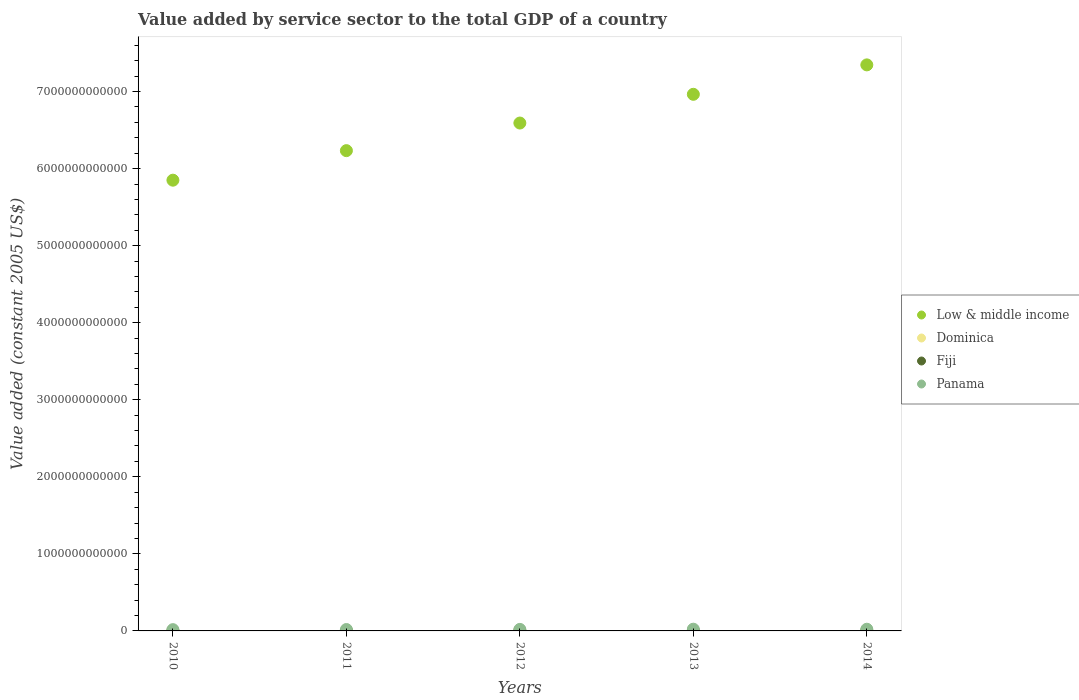Is the number of dotlines equal to the number of legend labels?
Provide a succinct answer. Yes. What is the value added by service sector in Fiji in 2013?
Give a very brief answer. 2.51e+09. Across all years, what is the maximum value added by service sector in Low & middle income?
Ensure brevity in your answer.  7.35e+12. Across all years, what is the minimum value added by service sector in Low & middle income?
Offer a terse response. 5.85e+12. In which year was the value added by service sector in Panama maximum?
Ensure brevity in your answer.  2013. In which year was the value added by service sector in Fiji minimum?
Keep it short and to the point. 2010. What is the total value added by service sector in Fiji in the graph?
Give a very brief answer. 1.19e+1. What is the difference between the value added by service sector in Low & middle income in 2012 and that in 2014?
Provide a short and direct response. -7.55e+11. What is the difference between the value added by service sector in Panama in 2014 and the value added by service sector in Low & middle income in 2012?
Give a very brief answer. -6.57e+12. What is the average value added by service sector in Fiji per year?
Your answer should be very brief. 2.37e+09. In the year 2013, what is the difference between the value added by service sector in Low & middle income and value added by service sector in Panama?
Your answer should be compact. 6.94e+12. What is the ratio of the value added by service sector in Panama in 2011 to that in 2012?
Provide a succinct answer. 0.92. Is the value added by service sector in Low & middle income in 2011 less than that in 2014?
Ensure brevity in your answer.  Yes. Is the difference between the value added by service sector in Low & middle income in 2013 and 2014 greater than the difference between the value added by service sector in Panama in 2013 and 2014?
Keep it short and to the point. No. What is the difference between the highest and the second highest value added by service sector in Panama?
Provide a succinct answer. 5.24e+08. What is the difference between the highest and the lowest value added by service sector in Dominica?
Your answer should be compact. 1.53e+07. Is the sum of the value added by service sector in Fiji in 2011 and 2012 greater than the maximum value added by service sector in Panama across all years?
Make the answer very short. No. Is the value added by service sector in Low & middle income strictly less than the value added by service sector in Panama over the years?
Provide a succinct answer. No. How many dotlines are there?
Offer a terse response. 4. How many years are there in the graph?
Ensure brevity in your answer.  5. What is the difference between two consecutive major ticks on the Y-axis?
Ensure brevity in your answer.  1.00e+12. Are the values on the major ticks of Y-axis written in scientific E-notation?
Your answer should be very brief. No. Does the graph contain any zero values?
Give a very brief answer. No. How many legend labels are there?
Ensure brevity in your answer.  4. What is the title of the graph?
Your answer should be very brief. Value added by service sector to the total GDP of a country. What is the label or title of the Y-axis?
Provide a short and direct response. Value added (constant 2005 US$). What is the Value added (constant 2005 US$) in Low & middle income in 2010?
Your response must be concise. 5.85e+12. What is the Value added (constant 2005 US$) in Dominica in 2010?
Offer a terse response. 2.59e+08. What is the Value added (constant 2005 US$) of Fiji in 2010?
Your answer should be compact. 1.95e+09. What is the Value added (constant 2005 US$) in Panama in 2010?
Offer a terse response. 1.65e+1. What is the Value added (constant 2005 US$) in Low & middle income in 2011?
Offer a very short reply. 6.23e+12. What is the Value added (constant 2005 US$) of Dominica in 2011?
Keep it short and to the point. 2.60e+08. What is the Value added (constant 2005 US$) of Fiji in 2011?
Your response must be concise. 2.33e+09. What is the Value added (constant 2005 US$) in Panama in 2011?
Give a very brief answer. 1.82e+1. What is the Value added (constant 2005 US$) in Low & middle income in 2012?
Ensure brevity in your answer.  6.59e+12. What is the Value added (constant 2005 US$) in Dominica in 2012?
Offer a terse response. 2.55e+08. What is the Value added (constant 2005 US$) of Fiji in 2012?
Offer a terse response. 2.40e+09. What is the Value added (constant 2005 US$) in Panama in 2012?
Provide a short and direct response. 1.98e+1. What is the Value added (constant 2005 US$) in Low & middle income in 2013?
Give a very brief answer. 6.96e+12. What is the Value added (constant 2005 US$) of Dominica in 2013?
Keep it short and to the point. 2.60e+08. What is the Value added (constant 2005 US$) of Fiji in 2013?
Provide a short and direct response. 2.51e+09. What is the Value added (constant 2005 US$) of Panama in 2013?
Your answer should be very brief. 2.24e+1. What is the Value added (constant 2005 US$) of Low & middle income in 2014?
Keep it short and to the point. 7.35e+12. What is the Value added (constant 2005 US$) of Dominica in 2014?
Make the answer very short. 2.70e+08. What is the Value added (constant 2005 US$) of Fiji in 2014?
Your answer should be compact. 2.68e+09. What is the Value added (constant 2005 US$) in Panama in 2014?
Make the answer very short. 2.19e+1. Across all years, what is the maximum Value added (constant 2005 US$) of Low & middle income?
Your response must be concise. 7.35e+12. Across all years, what is the maximum Value added (constant 2005 US$) in Dominica?
Offer a terse response. 2.70e+08. Across all years, what is the maximum Value added (constant 2005 US$) in Fiji?
Ensure brevity in your answer.  2.68e+09. Across all years, what is the maximum Value added (constant 2005 US$) in Panama?
Offer a terse response. 2.24e+1. Across all years, what is the minimum Value added (constant 2005 US$) of Low & middle income?
Offer a very short reply. 5.85e+12. Across all years, what is the minimum Value added (constant 2005 US$) of Dominica?
Offer a very short reply. 2.55e+08. Across all years, what is the minimum Value added (constant 2005 US$) in Fiji?
Make the answer very short. 1.95e+09. Across all years, what is the minimum Value added (constant 2005 US$) in Panama?
Your response must be concise. 1.65e+1. What is the total Value added (constant 2005 US$) of Low & middle income in the graph?
Your response must be concise. 3.30e+13. What is the total Value added (constant 2005 US$) in Dominica in the graph?
Offer a terse response. 1.30e+09. What is the total Value added (constant 2005 US$) of Fiji in the graph?
Give a very brief answer. 1.19e+1. What is the total Value added (constant 2005 US$) of Panama in the graph?
Provide a succinct answer. 9.90e+1. What is the difference between the Value added (constant 2005 US$) of Low & middle income in 2010 and that in 2011?
Your answer should be very brief. -3.83e+11. What is the difference between the Value added (constant 2005 US$) of Dominica in 2010 and that in 2011?
Provide a short and direct response. -8.58e+05. What is the difference between the Value added (constant 2005 US$) in Fiji in 2010 and that in 2011?
Offer a very short reply. -3.80e+08. What is the difference between the Value added (constant 2005 US$) of Panama in 2010 and that in 2011?
Provide a short and direct response. -1.68e+09. What is the difference between the Value added (constant 2005 US$) in Low & middle income in 2010 and that in 2012?
Your answer should be very brief. -7.42e+11. What is the difference between the Value added (constant 2005 US$) in Dominica in 2010 and that in 2012?
Your answer should be very brief. 4.85e+06. What is the difference between the Value added (constant 2005 US$) of Fiji in 2010 and that in 2012?
Provide a succinct answer. -4.51e+08. What is the difference between the Value added (constant 2005 US$) of Panama in 2010 and that in 2012?
Your answer should be compact. -3.31e+09. What is the difference between the Value added (constant 2005 US$) of Low & middle income in 2010 and that in 2013?
Offer a terse response. -1.11e+12. What is the difference between the Value added (constant 2005 US$) of Dominica in 2010 and that in 2013?
Offer a terse response. -1.63e+05. What is the difference between the Value added (constant 2005 US$) of Fiji in 2010 and that in 2013?
Give a very brief answer. -5.59e+08. What is the difference between the Value added (constant 2005 US$) in Panama in 2010 and that in 2013?
Provide a short and direct response. -5.91e+09. What is the difference between the Value added (constant 2005 US$) of Low & middle income in 2010 and that in 2014?
Your answer should be very brief. -1.50e+12. What is the difference between the Value added (constant 2005 US$) in Dominica in 2010 and that in 2014?
Your response must be concise. -1.04e+07. What is the difference between the Value added (constant 2005 US$) in Fiji in 2010 and that in 2014?
Make the answer very short. -7.32e+08. What is the difference between the Value added (constant 2005 US$) of Panama in 2010 and that in 2014?
Provide a succinct answer. -5.38e+09. What is the difference between the Value added (constant 2005 US$) of Low & middle income in 2011 and that in 2012?
Your answer should be very brief. -3.58e+11. What is the difference between the Value added (constant 2005 US$) in Dominica in 2011 and that in 2012?
Offer a very short reply. 5.71e+06. What is the difference between the Value added (constant 2005 US$) of Fiji in 2011 and that in 2012?
Keep it short and to the point. -7.08e+07. What is the difference between the Value added (constant 2005 US$) of Panama in 2011 and that in 2012?
Offer a very short reply. -1.63e+09. What is the difference between the Value added (constant 2005 US$) in Low & middle income in 2011 and that in 2013?
Your answer should be compact. -7.31e+11. What is the difference between the Value added (constant 2005 US$) of Dominica in 2011 and that in 2013?
Give a very brief answer. 6.94e+05. What is the difference between the Value added (constant 2005 US$) in Fiji in 2011 and that in 2013?
Your answer should be compact. -1.79e+08. What is the difference between the Value added (constant 2005 US$) of Panama in 2011 and that in 2013?
Provide a short and direct response. -4.23e+09. What is the difference between the Value added (constant 2005 US$) of Low & middle income in 2011 and that in 2014?
Provide a short and direct response. -1.11e+12. What is the difference between the Value added (constant 2005 US$) in Dominica in 2011 and that in 2014?
Your answer should be compact. -9.54e+06. What is the difference between the Value added (constant 2005 US$) of Fiji in 2011 and that in 2014?
Your response must be concise. -3.52e+08. What is the difference between the Value added (constant 2005 US$) in Panama in 2011 and that in 2014?
Your answer should be compact. -3.70e+09. What is the difference between the Value added (constant 2005 US$) in Low & middle income in 2012 and that in 2013?
Your answer should be very brief. -3.73e+11. What is the difference between the Value added (constant 2005 US$) of Dominica in 2012 and that in 2013?
Provide a succinct answer. -5.02e+06. What is the difference between the Value added (constant 2005 US$) in Fiji in 2012 and that in 2013?
Provide a short and direct response. -1.08e+08. What is the difference between the Value added (constant 2005 US$) of Panama in 2012 and that in 2013?
Provide a succinct answer. -2.60e+09. What is the difference between the Value added (constant 2005 US$) in Low & middle income in 2012 and that in 2014?
Ensure brevity in your answer.  -7.55e+11. What is the difference between the Value added (constant 2005 US$) in Dominica in 2012 and that in 2014?
Your answer should be compact. -1.53e+07. What is the difference between the Value added (constant 2005 US$) of Fiji in 2012 and that in 2014?
Make the answer very short. -2.81e+08. What is the difference between the Value added (constant 2005 US$) of Panama in 2012 and that in 2014?
Give a very brief answer. -2.07e+09. What is the difference between the Value added (constant 2005 US$) in Low & middle income in 2013 and that in 2014?
Offer a very short reply. -3.82e+11. What is the difference between the Value added (constant 2005 US$) of Dominica in 2013 and that in 2014?
Your answer should be compact. -1.02e+07. What is the difference between the Value added (constant 2005 US$) in Fiji in 2013 and that in 2014?
Ensure brevity in your answer.  -1.73e+08. What is the difference between the Value added (constant 2005 US$) of Panama in 2013 and that in 2014?
Make the answer very short. 5.24e+08. What is the difference between the Value added (constant 2005 US$) of Low & middle income in 2010 and the Value added (constant 2005 US$) of Dominica in 2011?
Ensure brevity in your answer.  5.85e+12. What is the difference between the Value added (constant 2005 US$) of Low & middle income in 2010 and the Value added (constant 2005 US$) of Fiji in 2011?
Provide a succinct answer. 5.85e+12. What is the difference between the Value added (constant 2005 US$) in Low & middle income in 2010 and the Value added (constant 2005 US$) in Panama in 2011?
Your answer should be compact. 5.83e+12. What is the difference between the Value added (constant 2005 US$) of Dominica in 2010 and the Value added (constant 2005 US$) of Fiji in 2011?
Your response must be concise. -2.07e+09. What is the difference between the Value added (constant 2005 US$) of Dominica in 2010 and the Value added (constant 2005 US$) of Panama in 2011?
Make the answer very short. -1.80e+1. What is the difference between the Value added (constant 2005 US$) in Fiji in 2010 and the Value added (constant 2005 US$) in Panama in 2011?
Your answer should be very brief. -1.63e+1. What is the difference between the Value added (constant 2005 US$) of Low & middle income in 2010 and the Value added (constant 2005 US$) of Dominica in 2012?
Provide a succinct answer. 5.85e+12. What is the difference between the Value added (constant 2005 US$) in Low & middle income in 2010 and the Value added (constant 2005 US$) in Fiji in 2012?
Give a very brief answer. 5.85e+12. What is the difference between the Value added (constant 2005 US$) of Low & middle income in 2010 and the Value added (constant 2005 US$) of Panama in 2012?
Offer a very short reply. 5.83e+12. What is the difference between the Value added (constant 2005 US$) in Dominica in 2010 and the Value added (constant 2005 US$) in Fiji in 2012?
Give a very brief answer. -2.14e+09. What is the difference between the Value added (constant 2005 US$) in Dominica in 2010 and the Value added (constant 2005 US$) in Panama in 2012?
Offer a terse response. -1.96e+1. What is the difference between the Value added (constant 2005 US$) of Fiji in 2010 and the Value added (constant 2005 US$) of Panama in 2012?
Offer a terse response. -1.79e+1. What is the difference between the Value added (constant 2005 US$) of Low & middle income in 2010 and the Value added (constant 2005 US$) of Dominica in 2013?
Keep it short and to the point. 5.85e+12. What is the difference between the Value added (constant 2005 US$) of Low & middle income in 2010 and the Value added (constant 2005 US$) of Fiji in 2013?
Give a very brief answer. 5.85e+12. What is the difference between the Value added (constant 2005 US$) of Low & middle income in 2010 and the Value added (constant 2005 US$) of Panama in 2013?
Your answer should be very brief. 5.83e+12. What is the difference between the Value added (constant 2005 US$) in Dominica in 2010 and the Value added (constant 2005 US$) in Fiji in 2013?
Your answer should be very brief. -2.25e+09. What is the difference between the Value added (constant 2005 US$) in Dominica in 2010 and the Value added (constant 2005 US$) in Panama in 2013?
Provide a succinct answer. -2.22e+1. What is the difference between the Value added (constant 2005 US$) of Fiji in 2010 and the Value added (constant 2005 US$) of Panama in 2013?
Keep it short and to the point. -2.05e+1. What is the difference between the Value added (constant 2005 US$) of Low & middle income in 2010 and the Value added (constant 2005 US$) of Dominica in 2014?
Your answer should be very brief. 5.85e+12. What is the difference between the Value added (constant 2005 US$) in Low & middle income in 2010 and the Value added (constant 2005 US$) in Fiji in 2014?
Keep it short and to the point. 5.85e+12. What is the difference between the Value added (constant 2005 US$) of Low & middle income in 2010 and the Value added (constant 2005 US$) of Panama in 2014?
Give a very brief answer. 5.83e+12. What is the difference between the Value added (constant 2005 US$) of Dominica in 2010 and the Value added (constant 2005 US$) of Fiji in 2014?
Keep it short and to the point. -2.42e+09. What is the difference between the Value added (constant 2005 US$) in Dominica in 2010 and the Value added (constant 2005 US$) in Panama in 2014?
Your answer should be compact. -2.17e+1. What is the difference between the Value added (constant 2005 US$) in Fiji in 2010 and the Value added (constant 2005 US$) in Panama in 2014?
Provide a succinct answer. -2.00e+1. What is the difference between the Value added (constant 2005 US$) in Low & middle income in 2011 and the Value added (constant 2005 US$) in Dominica in 2012?
Keep it short and to the point. 6.23e+12. What is the difference between the Value added (constant 2005 US$) of Low & middle income in 2011 and the Value added (constant 2005 US$) of Fiji in 2012?
Your answer should be compact. 6.23e+12. What is the difference between the Value added (constant 2005 US$) of Low & middle income in 2011 and the Value added (constant 2005 US$) of Panama in 2012?
Offer a very short reply. 6.21e+12. What is the difference between the Value added (constant 2005 US$) of Dominica in 2011 and the Value added (constant 2005 US$) of Fiji in 2012?
Your response must be concise. -2.14e+09. What is the difference between the Value added (constant 2005 US$) of Dominica in 2011 and the Value added (constant 2005 US$) of Panama in 2012?
Offer a terse response. -1.96e+1. What is the difference between the Value added (constant 2005 US$) of Fiji in 2011 and the Value added (constant 2005 US$) of Panama in 2012?
Offer a terse response. -1.75e+1. What is the difference between the Value added (constant 2005 US$) of Low & middle income in 2011 and the Value added (constant 2005 US$) of Dominica in 2013?
Keep it short and to the point. 6.23e+12. What is the difference between the Value added (constant 2005 US$) in Low & middle income in 2011 and the Value added (constant 2005 US$) in Fiji in 2013?
Your answer should be compact. 6.23e+12. What is the difference between the Value added (constant 2005 US$) of Low & middle income in 2011 and the Value added (constant 2005 US$) of Panama in 2013?
Offer a terse response. 6.21e+12. What is the difference between the Value added (constant 2005 US$) in Dominica in 2011 and the Value added (constant 2005 US$) in Fiji in 2013?
Make the answer very short. -2.25e+09. What is the difference between the Value added (constant 2005 US$) in Dominica in 2011 and the Value added (constant 2005 US$) in Panama in 2013?
Provide a succinct answer. -2.22e+1. What is the difference between the Value added (constant 2005 US$) of Fiji in 2011 and the Value added (constant 2005 US$) of Panama in 2013?
Offer a terse response. -2.01e+1. What is the difference between the Value added (constant 2005 US$) in Low & middle income in 2011 and the Value added (constant 2005 US$) in Dominica in 2014?
Provide a short and direct response. 6.23e+12. What is the difference between the Value added (constant 2005 US$) of Low & middle income in 2011 and the Value added (constant 2005 US$) of Fiji in 2014?
Ensure brevity in your answer.  6.23e+12. What is the difference between the Value added (constant 2005 US$) in Low & middle income in 2011 and the Value added (constant 2005 US$) in Panama in 2014?
Your answer should be very brief. 6.21e+12. What is the difference between the Value added (constant 2005 US$) in Dominica in 2011 and the Value added (constant 2005 US$) in Fiji in 2014?
Keep it short and to the point. -2.42e+09. What is the difference between the Value added (constant 2005 US$) of Dominica in 2011 and the Value added (constant 2005 US$) of Panama in 2014?
Your answer should be very brief. -2.17e+1. What is the difference between the Value added (constant 2005 US$) of Fiji in 2011 and the Value added (constant 2005 US$) of Panama in 2014?
Your answer should be very brief. -1.96e+1. What is the difference between the Value added (constant 2005 US$) in Low & middle income in 2012 and the Value added (constant 2005 US$) in Dominica in 2013?
Give a very brief answer. 6.59e+12. What is the difference between the Value added (constant 2005 US$) of Low & middle income in 2012 and the Value added (constant 2005 US$) of Fiji in 2013?
Make the answer very short. 6.59e+12. What is the difference between the Value added (constant 2005 US$) of Low & middle income in 2012 and the Value added (constant 2005 US$) of Panama in 2013?
Your answer should be compact. 6.57e+12. What is the difference between the Value added (constant 2005 US$) in Dominica in 2012 and the Value added (constant 2005 US$) in Fiji in 2013?
Provide a succinct answer. -2.25e+09. What is the difference between the Value added (constant 2005 US$) of Dominica in 2012 and the Value added (constant 2005 US$) of Panama in 2013?
Your answer should be compact. -2.22e+1. What is the difference between the Value added (constant 2005 US$) of Fiji in 2012 and the Value added (constant 2005 US$) of Panama in 2013?
Ensure brevity in your answer.  -2.00e+1. What is the difference between the Value added (constant 2005 US$) of Low & middle income in 2012 and the Value added (constant 2005 US$) of Dominica in 2014?
Your response must be concise. 6.59e+12. What is the difference between the Value added (constant 2005 US$) in Low & middle income in 2012 and the Value added (constant 2005 US$) in Fiji in 2014?
Make the answer very short. 6.59e+12. What is the difference between the Value added (constant 2005 US$) in Low & middle income in 2012 and the Value added (constant 2005 US$) in Panama in 2014?
Offer a terse response. 6.57e+12. What is the difference between the Value added (constant 2005 US$) in Dominica in 2012 and the Value added (constant 2005 US$) in Fiji in 2014?
Offer a very short reply. -2.43e+09. What is the difference between the Value added (constant 2005 US$) in Dominica in 2012 and the Value added (constant 2005 US$) in Panama in 2014?
Keep it short and to the point. -2.17e+1. What is the difference between the Value added (constant 2005 US$) in Fiji in 2012 and the Value added (constant 2005 US$) in Panama in 2014?
Your answer should be very brief. -1.95e+1. What is the difference between the Value added (constant 2005 US$) of Low & middle income in 2013 and the Value added (constant 2005 US$) of Dominica in 2014?
Offer a terse response. 6.96e+12. What is the difference between the Value added (constant 2005 US$) of Low & middle income in 2013 and the Value added (constant 2005 US$) of Fiji in 2014?
Offer a very short reply. 6.96e+12. What is the difference between the Value added (constant 2005 US$) of Low & middle income in 2013 and the Value added (constant 2005 US$) of Panama in 2014?
Offer a terse response. 6.94e+12. What is the difference between the Value added (constant 2005 US$) in Dominica in 2013 and the Value added (constant 2005 US$) in Fiji in 2014?
Keep it short and to the point. -2.42e+09. What is the difference between the Value added (constant 2005 US$) in Dominica in 2013 and the Value added (constant 2005 US$) in Panama in 2014?
Your answer should be very brief. -2.17e+1. What is the difference between the Value added (constant 2005 US$) of Fiji in 2013 and the Value added (constant 2005 US$) of Panama in 2014?
Make the answer very short. -1.94e+1. What is the average Value added (constant 2005 US$) in Low & middle income per year?
Your response must be concise. 6.60e+12. What is the average Value added (constant 2005 US$) in Dominica per year?
Your response must be concise. 2.61e+08. What is the average Value added (constant 2005 US$) in Fiji per year?
Offer a very short reply. 2.37e+09. What is the average Value added (constant 2005 US$) of Panama per year?
Give a very brief answer. 1.98e+1. In the year 2010, what is the difference between the Value added (constant 2005 US$) of Low & middle income and Value added (constant 2005 US$) of Dominica?
Make the answer very short. 5.85e+12. In the year 2010, what is the difference between the Value added (constant 2005 US$) of Low & middle income and Value added (constant 2005 US$) of Fiji?
Your answer should be compact. 5.85e+12. In the year 2010, what is the difference between the Value added (constant 2005 US$) in Low & middle income and Value added (constant 2005 US$) in Panama?
Offer a very short reply. 5.83e+12. In the year 2010, what is the difference between the Value added (constant 2005 US$) in Dominica and Value added (constant 2005 US$) in Fiji?
Your response must be concise. -1.69e+09. In the year 2010, what is the difference between the Value added (constant 2005 US$) of Dominica and Value added (constant 2005 US$) of Panama?
Offer a very short reply. -1.63e+1. In the year 2010, what is the difference between the Value added (constant 2005 US$) in Fiji and Value added (constant 2005 US$) in Panama?
Give a very brief answer. -1.46e+1. In the year 2011, what is the difference between the Value added (constant 2005 US$) of Low & middle income and Value added (constant 2005 US$) of Dominica?
Make the answer very short. 6.23e+12. In the year 2011, what is the difference between the Value added (constant 2005 US$) of Low & middle income and Value added (constant 2005 US$) of Fiji?
Provide a succinct answer. 6.23e+12. In the year 2011, what is the difference between the Value added (constant 2005 US$) in Low & middle income and Value added (constant 2005 US$) in Panama?
Your answer should be very brief. 6.21e+12. In the year 2011, what is the difference between the Value added (constant 2005 US$) in Dominica and Value added (constant 2005 US$) in Fiji?
Your response must be concise. -2.07e+09. In the year 2011, what is the difference between the Value added (constant 2005 US$) of Dominica and Value added (constant 2005 US$) of Panama?
Give a very brief answer. -1.80e+1. In the year 2011, what is the difference between the Value added (constant 2005 US$) in Fiji and Value added (constant 2005 US$) in Panama?
Your response must be concise. -1.59e+1. In the year 2012, what is the difference between the Value added (constant 2005 US$) in Low & middle income and Value added (constant 2005 US$) in Dominica?
Make the answer very short. 6.59e+12. In the year 2012, what is the difference between the Value added (constant 2005 US$) in Low & middle income and Value added (constant 2005 US$) in Fiji?
Make the answer very short. 6.59e+12. In the year 2012, what is the difference between the Value added (constant 2005 US$) of Low & middle income and Value added (constant 2005 US$) of Panama?
Keep it short and to the point. 6.57e+12. In the year 2012, what is the difference between the Value added (constant 2005 US$) of Dominica and Value added (constant 2005 US$) of Fiji?
Your answer should be compact. -2.14e+09. In the year 2012, what is the difference between the Value added (constant 2005 US$) of Dominica and Value added (constant 2005 US$) of Panama?
Your answer should be very brief. -1.96e+1. In the year 2012, what is the difference between the Value added (constant 2005 US$) of Fiji and Value added (constant 2005 US$) of Panama?
Offer a terse response. -1.74e+1. In the year 2013, what is the difference between the Value added (constant 2005 US$) of Low & middle income and Value added (constant 2005 US$) of Dominica?
Ensure brevity in your answer.  6.96e+12. In the year 2013, what is the difference between the Value added (constant 2005 US$) of Low & middle income and Value added (constant 2005 US$) of Fiji?
Your answer should be compact. 6.96e+12. In the year 2013, what is the difference between the Value added (constant 2005 US$) of Low & middle income and Value added (constant 2005 US$) of Panama?
Offer a very short reply. 6.94e+12. In the year 2013, what is the difference between the Value added (constant 2005 US$) in Dominica and Value added (constant 2005 US$) in Fiji?
Your answer should be very brief. -2.25e+09. In the year 2013, what is the difference between the Value added (constant 2005 US$) of Dominica and Value added (constant 2005 US$) of Panama?
Offer a terse response. -2.22e+1. In the year 2013, what is the difference between the Value added (constant 2005 US$) of Fiji and Value added (constant 2005 US$) of Panama?
Your response must be concise. -1.99e+1. In the year 2014, what is the difference between the Value added (constant 2005 US$) in Low & middle income and Value added (constant 2005 US$) in Dominica?
Keep it short and to the point. 7.35e+12. In the year 2014, what is the difference between the Value added (constant 2005 US$) in Low & middle income and Value added (constant 2005 US$) in Fiji?
Your response must be concise. 7.34e+12. In the year 2014, what is the difference between the Value added (constant 2005 US$) in Low & middle income and Value added (constant 2005 US$) in Panama?
Your answer should be very brief. 7.32e+12. In the year 2014, what is the difference between the Value added (constant 2005 US$) of Dominica and Value added (constant 2005 US$) of Fiji?
Provide a succinct answer. -2.41e+09. In the year 2014, what is the difference between the Value added (constant 2005 US$) in Dominica and Value added (constant 2005 US$) in Panama?
Keep it short and to the point. -2.17e+1. In the year 2014, what is the difference between the Value added (constant 2005 US$) of Fiji and Value added (constant 2005 US$) of Panama?
Your answer should be compact. -1.92e+1. What is the ratio of the Value added (constant 2005 US$) of Low & middle income in 2010 to that in 2011?
Offer a very short reply. 0.94. What is the ratio of the Value added (constant 2005 US$) of Fiji in 2010 to that in 2011?
Ensure brevity in your answer.  0.84. What is the ratio of the Value added (constant 2005 US$) of Panama in 2010 to that in 2011?
Provide a short and direct response. 0.91. What is the ratio of the Value added (constant 2005 US$) of Low & middle income in 2010 to that in 2012?
Provide a succinct answer. 0.89. What is the ratio of the Value added (constant 2005 US$) in Dominica in 2010 to that in 2012?
Your answer should be very brief. 1.02. What is the ratio of the Value added (constant 2005 US$) in Fiji in 2010 to that in 2012?
Your response must be concise. 0.81. What is the ratio of the Value added (constant 2005 US$) in Panama in 2010 to that in 2012?
Provide a short and direct response. 0.83. What is the ratio of the Value added (constant 2005 US$) in Low & middle income in 2010 to that in 2013?
Ensure brevity in your answer.  0.84. What is the ratio of the Value added (constant 2005 US$) of Dominica in 2010 to that in 2013?
Your answer should be very brief. 1. What is the ratio of the Value added (constant 2005 US$) in Fiji in 2010 to that in 2013?
Keep it short and to the point. 0.78. What is the ratio of the Value added (constant 2005 US$) in Panama in 2010 to that in 2013?
Provide a succinct answer. 0.74. What is the ratio of the Value added (constant 2005 US$) in Low & middle income in 2010 to that in 2014?
Make the answer very short. 0.8. What is the ratio of the Value added (constant 2005 US$) in Dominica in 2010 to that in 2014?
Offer a terse response. 0.96. What is the ratio of the Value added (constant 2005 US$) of Fiji in 2010 to that in 2014?
Keep it short and to the point. 0.73. What is the ratio of the Value added (constant 2005 US$) of Panama in 2010 to that in 2014?
Offer a very short reply. 0.75. What is the ratio of the Value added (constant 2005 US$) in Low & middle income in 2011 to that in 2012?
Offer a very short reply. 0.95. What is the ratio of the Value added (constant 2005 US$) in Dominica in 2011 to that in 2012?
Make the answer very short. 1.02. What is the ratio of the Value added (constant 2005 US$) of Fiji in 2011 to that in 2012?
Your answer should be very brief. 0.97. What is the ratio of the Value added (constant 2005 US$) in Panama in 2011 to that in 2012?
Keep it short and to the point. 0.92. What is the ratio of the Value added (constant 2005 US$) in Low & middle income in 2011 to that in 2013?
Your answer should be very brief. 0.9. What is the ratio of the Value added (constant 2005 US$) of Dominica in 2011 to that in 2013?
Your response must be concise. 1. What is the ratio of the Value added (constant 2005 US$) in Fiji in 2011 to that in 2013?
Offer a very short reply. 0.93. What is the ratio of the Value added (constant 2005 US$) of Panama in 2011 to that in 2013?
Provide a short and direct response. 0.81. What is the ratio of the Value added (constant 2005 US$) in Low & middle income in 2011 to that in 2014?
Keep it short and to the point. 0.85. What is the ratio of the Value added (constant 2005 US$) of Dominica in 2011 to that in 2014?
Ensure brevity in your answer.  0.96. What is the ratio of the Value added (constant 2005 US$) of Fiji in 2011 to that in 2014?
Provide a succinct answer. 0.87. What is the ratio of the Value added (constant 2005 US$) of Panama in 2011 to that in 2014?
Offer a very short reply. 0.83. What is the ratio of the Value added (constant 2005 US$) of Low & middle income in 2012 to that in 2013?
Make the answer very short. 0.95. What is the ratio of the Value added (constant 2005 US$) in Dominica in 2012 to that in 2013?
Make the answer very short. 0.98. What is the ratio of the Value added (constant 2005 US$) in Fiji in 2012 to that in 2013?
Your answer should be compact. 0.96. What is the ratio of the Value added (constant 2005 US$) of Panama in 2012 to that in 2013?
Your response must be concise. 0.88. What is the ratio of the Value added (constant 2005 US$) in Low & middle income in 2012 to that in 2014?
Ensure brevity in your answer.  0.9. What is the ratio of the Value added (constant 2005 US$) of Dominica in 2012 to that in 2014?
Your answer should be compact. 0.94. What is the ratio of the Value added (constant 2005 US$) of Fiji in 2012 to that in 2014?
Your response must be concise. 0.9. What is the ratio of the Value added (constant 2005 US$) of Panama in 2012 to that in 2014?
Offer a very short reply. 0.91. What is the ratio of the Value added (constant 2005 US$) in Low & middle income in 2013 to that in 2014?
Offer a very short reply. 0.95. What is the ratio of the Value added (constant 2005 US$) of Dominica in 2013 to that in 2014?
Ensure brevity in your answer.  0.96. What is the ratio of the Value added (constant 2005 US$) of Fiji in 2013 to that in 2014?
Make the answer very short. 0.94. What is the ratio of the Value added (constant 2005 US$) of Panama in 2013 to that in 2014?
Provide a short and direct response. 1.02. What is the difference between the highest and the second highest Value added (constant 2005 US$) in Low & middle income?
Provide a succinct answer. 3.82e+11. What is the difference between the highest and the second highest Value added (constant 2005 US$) in Dominica?
Offer a terse response. 9.54e+06. What is the difference between the highest and the second highest Value added (constant 2005 US$) in Fiji?
Provide a short and direct response. 1.73e+08. What is the difference between the highest and the second highest Value added (constant 2005 US$) of Panama?
Your answer should be very brief. 5.24e+08. What is the difference between the highest and the lowest Value added (constant 2005 US$) in Low & middle income?
Your response must be concise. 1.50e+12. What is the difference between the highest and the lowest Value added (constant 2005 US$) of Dominica?
Offer a very short reply. 1.53e+07. What is the difference between the highest and the lowest Value added (constant 2005 US$) of Fiji?
Give a very brief answer. 7.32e+08. What is the difference between the highest and the lowest Value added (constant 2005 US$) of Panama?
Make the answer very short. 5.91e+09. 